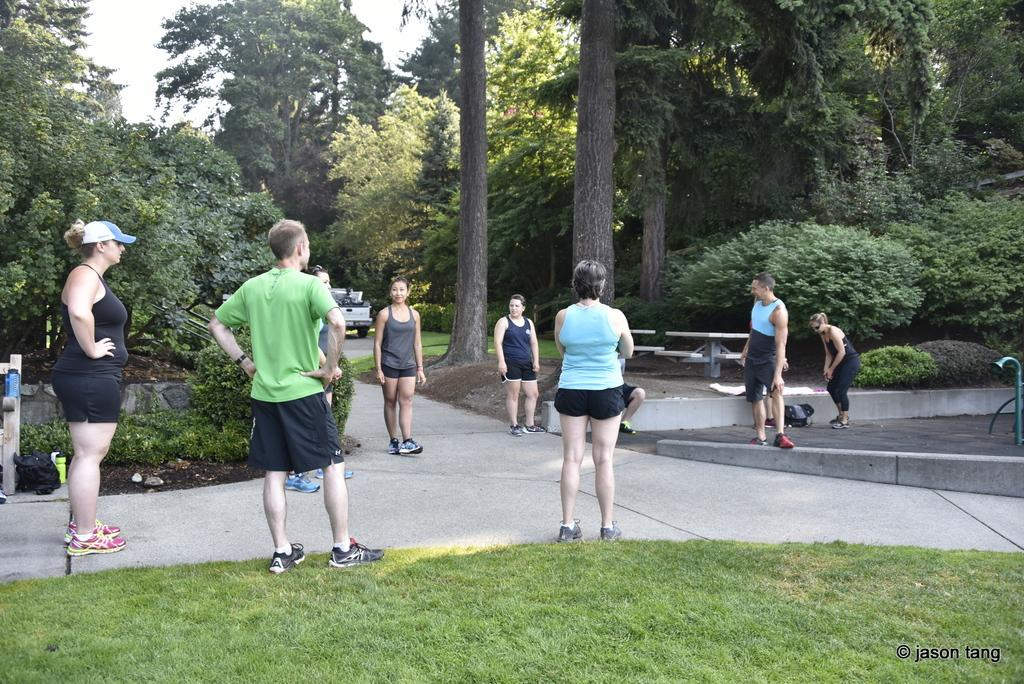How many people can be seen in the image? There are people in the image, but the exact number cannot be determined from the provided facts. What type of surface is visible beneath the people? There is grass in the image, which suggests that the people are standing on a grassy area. What other objects or features can be seen in the image? In addition to the people and grass, there are plants, benches, a road, a vehicle, trees, and the sky visible in the image. What type of oven is being used to cook the stocking in the image? There is no oven or stocking present in the image; it features people, grass, plants, benches, a road, a vehicle, trees, and the sky. 